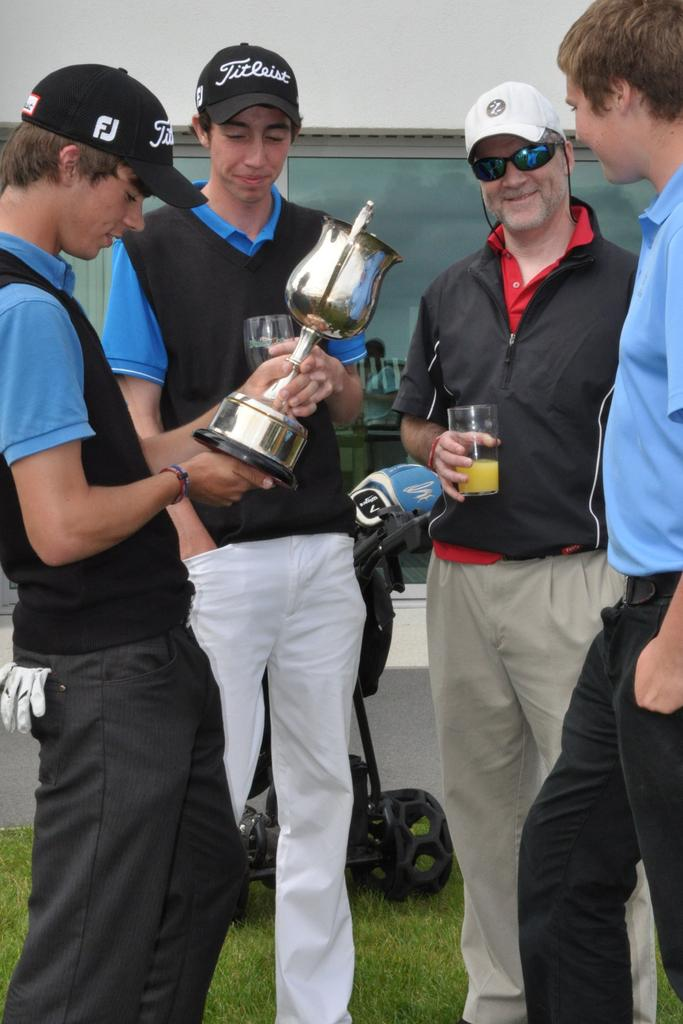<image>
Summarize the visual content of the image. a couple people wearing hats with the letters FJ on it 